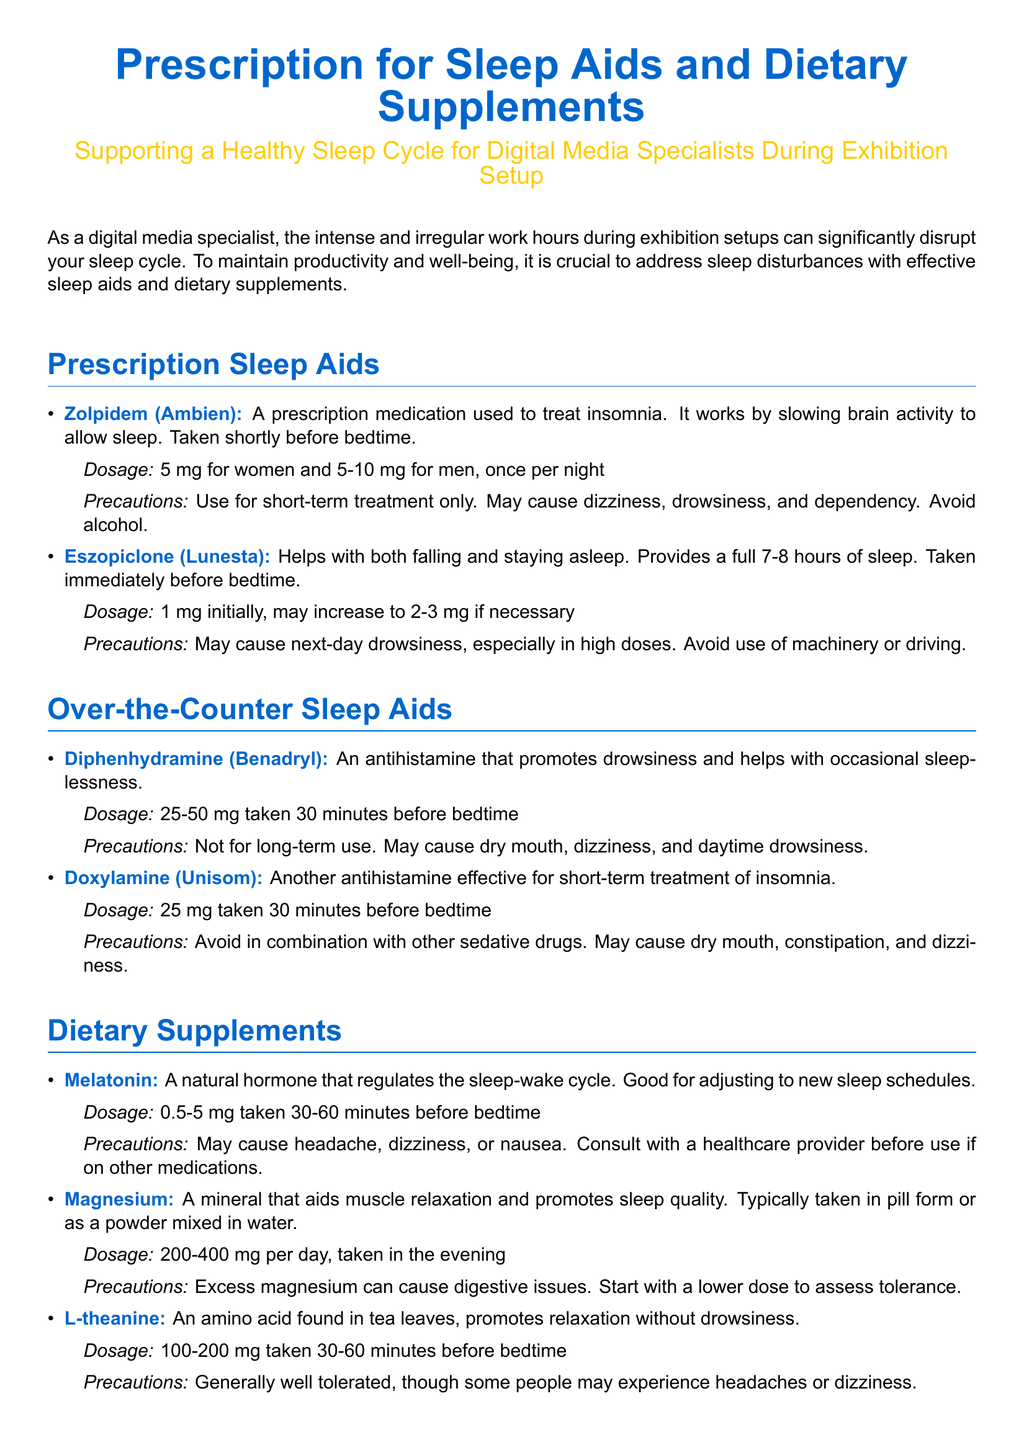What is the title of the document? The title of the document is presented prominently at the beginning, indicating its main topic related to sleep aids.
Answer: Prescription for Sleep Aids and Dietary Supplements What is the primary purpose of the document? The document aims to offer guidance on managing sleep for digital media specialists who experience disrupted sleep cycles.
Answer: Supporting a Healthy Sleep Cycle What dosage of Zolpidem is recommended for women? The document specifies the dosage of Zolpidem specifically for women, providing clarity on its use.
Answer: 5 mg What is a precaution for using Eszopiclone? The document lists the precautionary measures surrounding the use of Eszopiclone.
Answer: May cause next-day drowsiness What is the recommended dosage for Melatonin? The dosage for Melatonin is clearly stated in the supplement section of the document.
Answer: 0.5-5 mg Which lifestyle recommendation helps in creating a restful sleeping environment? One of the lifestyle recommendations mentions how to enhance the sleep setting for better rest.
Answer: dark, quiet, and cool What is a treatment method for insomnia mentioned in the over-the-counter sleep aids section? The document includes specific medications that are recognized for their effectiveness in treating insomnia.
Answer: Diphenhydramine (Benadryl) What is a note of concern regarding magnesium supplementation? The document highlights a potential side effect related to excessive magnesium intake.
Answer: digestive issues What should you avoid close to bedtime? The document recommends avoiding specific substances or activities that might disrupt sleep.
Answer: stimulants 